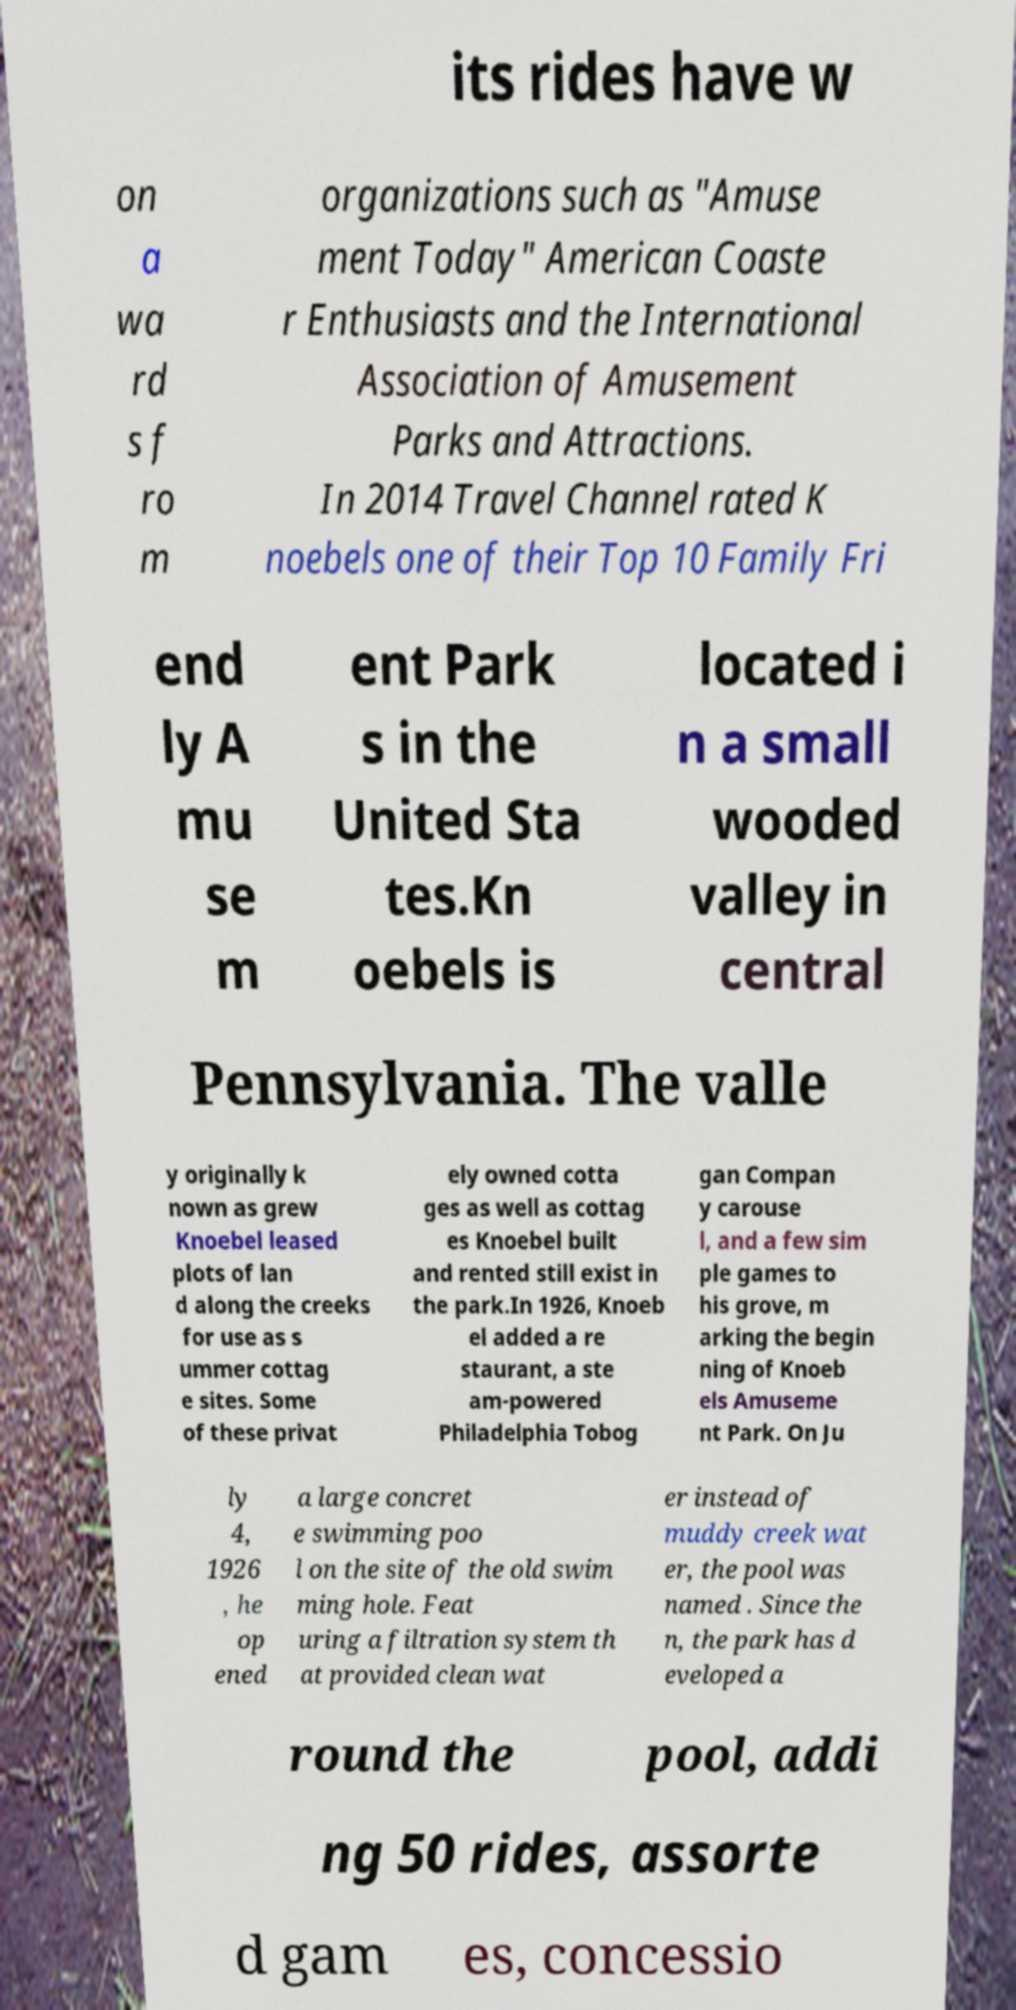For documentation purposes, I need the text within this image transcribed. Could you provide that? its rides have w on a wa rd s f ro m organizations such as "Amuse ment Today" American Coaste r Enthusiasts and the International Association of Amusement Parks and Attractions. In 2014 Travel Channel rated K noebels one of their Top 10 Family Fri end ly A mu se m ent Park s in the United Sta tes.Kn oebels is located i n a small wooded valley in central Pennsylvania. The valle y originally k nown as grew Knoebel leased plots of lan d along the creeks for use as s ummer cottag e sites. Some of these privat ely owned cotta ges as well as cottag es Knoebel built and rented still exist in the park.In 1926, Knoeb el added a re staurant, a ste am-powered Philadelphia Tobog gan Compan y carouse l, and a few sim ple games to his grove, m arking the begin ning of Knoeb els Amuseme nt Park. On Ju ly 4, 1926 , he op ened a large concret e swimming poo l on the site of the old swim ming hole. Feat uring a filtration system th at provided clean wat er instead of muddy creek wat er, the pool was named . Since the n, the park has d eveloped a round the pool, addi ng 50 rides, assorte d gam es, concessio 